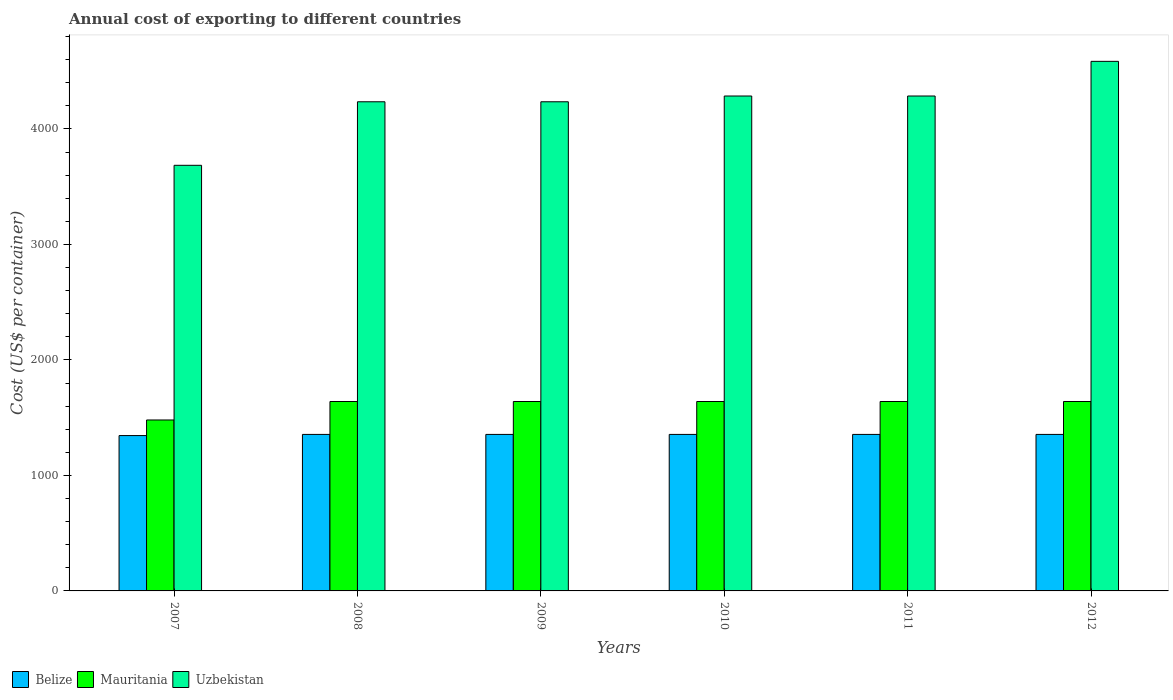How many bars are there on the 4th tick from the left?
Your answer should be compact. 3. How many bars are there on the 1st tick from the right?
Make the answer very short. 3. In how many cases, is the number of bars for a given year not equal to the number of legend labels?
Provide a short and direct response. 0. What is the total annual cost of exporting in Belize in 2009?
Give a very brief answer. 1355. Across all years, what is the maximum total annual cost of exporting in Belize?
Provide a short and direct response. 1355. Across all years, what is the minimum total annual cost of exporting in Belize?
Keep it short and to the point. 1345. In which year was the total annual cost of exporting in Uzbekistan maximum?
Offer a very short reply. 2012. In which year was the total annual cost of exporting in Uzbekistan minimum?
Your answer should be compact. 2007. What is the total total annual cost of exporting in Mauritania in the graph?
Your answer should be very brief. 9680. What is the difference between the total annual cost of exporting in Uzbekistan in 2007 and that in 2012?
Offer a terse response. -900. What is the difference between the total annual cost of exporting in Uzbekistan in 2010 and the total annual cost of exporting in Mauritania in 2009?
Your response must be concise. 2645. What is the average total annual cost of exporting in Belize per year?
Offer a terse response. 1353.33. In the year 2007, what is the difference between the total annual cost of exporting in Uzbekistan and total annual cost of exporting in Belize?
Your response must be concise. 2340. What is the ratio of the total annual cost of exporting in Belize in 2008 to that in 2010?
Give a very brief answer. 1. What is the difference between the highest and the second highest total annual cost of exporting in Uzbekistan?
Provide a short and direct response. 300. What is the difference between the highest and the lowest total annual cost of exporting in Belize?
Keep it short and to the point. 10. What does the 1st bar from the left in 2009 represents?
Your answer should be compact. Belize. What does the 2nd bar from the right in 2009 represents?
Your response must be concise. Mauritania. Is it the case that in every year, the sum of the total annual cost of exporting in Belize and total annual cost of exporting in Uzbekistan is greater than the total annual cost of exporting in Mauritania?
Your response must be concise. Yes. Are all the bars in the graph horizontal?
Your response must be concise. No. What is the difference between two consecutive major ticks on the Y-axis?
Your answer should be compact. 1000. Are the values on the major ticks of Y-axis written in scientific E-notation?
Offer a very short reply. No. Does the graph contain any zero values?
Your answer should be very brief. No. How many legend labels are there?
Your answer should be very brief. 3. How are the legend labels stacked?
Ensure brevity in your answer.  Horizontal. What is the title of the graph?
Offer a terse response. Annual cost of exporting to different countries. Does "Latin America(developing only)" appear as one of the legend labels in the graph?
Ensure brevity in your answer.  No. What is the label or title of the Y-axis?
Your answer should be very brief. Cost (US$ per container). What is the Cost (US$ per container) in Belize in 2007?
Provide a succinct answer. 1345. What is the Cost (US$ per container) in Mauritania in 2007?
Provide a succinct answer. 1480. What is the Cost (US$ per container) of Uzbekistan in 2007?
Offer a very short reply. 3685. What is the Cost (US$ per container) in Belize in 2008?
Give a very brief answer. 1355. What is the Cost (US$ per container) of Mauritania in 2008?
Your answer should be very brief. 1640. What is the Cost (US$ per container) in Uzbekistan in 2008?
Keep it short and to the point. 4235. What is the Cost (US$ per container) in Belize in 2009?
Your answer should be compact. 1355. What is the Cost (US$ per container) in Mauritania in 2009?
Ensure brevity in your answer.  1640. What is the Cost (US$ per container) of Uzbekistan in 2009?
Your answer should be compact. 4235. What is the Cost (US$ per container) of Belize in 2010?
Offer a very short reply. 1355. What is the Cost (US$ per container) of Mauritania in 2010?
Keep it short and to the point. 1640. What is the Cost (US$ per container) of Uzbekistan in 2010?
Your answer should be compact. 4285. What is the Cost (US$ per container) in Belize in 2011?
Keep it short and to the point. 1355. What is the Cost (US$ per container) in Mauritania in 2011?
Keep it short and to the point. 1640. What is the Cost (US$ per container) in Uzbekistan in 2011?
Ensure brevity in your answer.  4285. What is the Cost (US$ per container) in Belize in 2012?
Ensure brevity in your answer.  1355. What is the Cost (US$ per container) in Mauritania in 2012?
Offer a terse response. 1640. What is the Cost (US$ per container) in Uzbekistan in 2012?
Give a very brief answer. 4585. Across all years, what is the maximum Cost (US$ per container) of Belize?
Provide a short and direct response. 1355. Across all years, what is the maximum Cost (US$ per container) in Mauritania?
Your response must be concise. 1640. Across all years, what is the maximum Cost (US$ per container) in Uzbekistan?
Make the answer very short. 4585. Across all years, what is the minimum Cost (US$ per container) in Belize?
Your answer should be compact. 1345. Across all years, what is the minimum Cost (US$ per container) in Mauritania?
Offer a very short reply. 1480. Across all years, what is the minimum Cost (US$ per container) of Uzbekistan?
Keep it short and to the point. 3685. What is the total Cost (US$ per container) in Belize in the graph?
Offer a very short reply. 8120. What is the total Cost (US$ per container) in Mauritania in the graph?
Your answer should be compact. 9680. What is the total Cost (US$ per container) of Uzbekistan in the graph?
Keep it short and to the point. 2.53e+04. What is the difference between the Cost (US$ per container) of Mauritania in 2007 and that in 2008?
Make the answer very short. -160. What is the difference between the Cost (US$ per container) of Uzbekistan in 2007 and that in 2008?
Ensure brevity in your answer.  -550. What is the difference between the Cost (US$ per container) of Belize in 2007 and that in 2009?
Your answer should be very brief. -10. What is the difference between the Cost (US$ per container) in Mauritania in 2007 and that in 2009?
Make the answer very short. -160. What is the difference between the Cost (US$ per container) in Uzbekistan in 2007 and that in 2009?
Provide a short and direct response. -550. What is the difference between the Cost (US$ per container) of Belize in 2007 and that in 2010?
Keep it short and to the point. -10. What is the difference between the Cost (US$ per container) of Mauritania in 2007 and that in 2010?
Your response must be concise. -160. What is the difference between the Cost (US$ per container) of Uzbekistan in 2007 and that in 2010?
Provide a succinct answer. -600. What is the difference between the Cost (US$ per container) of Mauritania in 2007 and that in 2011?
Your answer should be very brief. -160. What is the difference between the Cost (US$ per container) of Uzbekistan in 2007 and that in 2011?
Your answer should be very brief. -600. What is the difference between the Cost (US$ per container) of Mauritania in 2007 and that in 2012?
Provide a short and direct response. -160. What is the difference between the Cost (US$ per container) of Uzbekistan in 2007 and that in 2012?
Your response must be concise. -900. What is the difference between the Cost (US$ per container) of Belize in 2008 and that in 2009?
Offer a terse response. 0. What is the difference between the Cost (US$ per container) of Mauritania in 2008 and that in 2009?
Provide a succinct answer. 0. What is the difference between the Cost (US$ per container) of Mauritania in 2008 and that in 2010?
Keep it short and to the point. 0. What is the difference between the Cost (US$ per container) in Uzbekistan in 2008 and that in 2010?
Offer a terse response. -50. What is the difference between the Cost (US$ per container) of Belize in 2008 and that in 2011?
Ensure brevity in your answer.  0. What is the difference between the Cost (US$ per container) of Uzbekistan in 2008 and that in 2011?
Offer a terse response. -50. What is the difference between the Cost (US$ per container) in Uzbekistan in 2008 and that in 2012?
Offer a very short reply. -350. What is the difference between the Cost (US$ per container) in Mauritania in 2009 and that in 2010?
Your response must be concise. 0. What is the difference between the Cost (US$ per container) of Uzbekistan in 2009 and that in 2010?
Your response must be concise. -50. What is the difference between the Cost (US$ per container) of Uzbekistan in 2009 and that in 2012?
Ensure brevity in your answer.  -350. What is the difference between the Cost (US$ per container) in Belize in 2010 and that in 2011?
Give a very brief answer. 0. What is the difference between the Cost (US$ per container) in Uzbekistan in 2010 and that in 2011?
Your answer should be very brief. 0. What is the difference between the Cost (US$ per container) of Belize in 2010 and that in 2012?
Provide a succinct answer. 0. What is the difference between the Cost (US$ per container) in Mauritania in 2010 and that in 2012?
Make the answer very short. 0. What is the difference between the Cost (US$ per container) of Uzbekistan in 2010 and that in 2012?
Give a very brief answer. -300. What is the difference between the Cost (US$ per container) in Mauritania in 2011 and that in 2012?
Your response must be concise. 0. What is the difference between the Cost (US$ per container) in Uzbekistan in 2011 and that in 2012?
Give a very brief answer. -300. What is the difference between the Cost (US$ per container) in Belize in 2007 and the Cost (US$ per container) in Mauritania in 2008?
Keep it short and to the point. -295. What is the difference between the Cost (US$ per container) in Belize in 2007 and the Cost (US$ per container) in Uzbekistan in 2008?
Ensure brevity in your answer.  -2890. What is the difference between the Cost (US$ per container) of Mauritania in 2007 and the Cost (US$ per container) of Uzbekistan in 2008?
Offer a terse response. -2755. What is the difference between the Cost (US$ per container) in Belize in 2007 and the Cost (US$ per container) in Mauritania in 2009?
Your answer should be compact. -295. What is the difference between the Cost (US$ per container) of Belize in 2007 and the Cost (US$ per container) of Uzbekistan in 2009?
Make the answer very short. -2890. What is the difference between the Cost (US$ per container) of Mauritania in 2007 and the Cost (US$ per container) of Uzbekistan in 2009?
Offer a terse response. -2755. What is the difference between the Cost (US$ per container) of Belize in 2007 and the Cost (US$ per container) of Mauritania in 2010?
Ensure brevity in your answer.  -295. What is the difference between the Cost (US$ per container) of Belize in 2007 and the Cost (US$ per container) of Uzbekistan in 2010?
Offer a very short reply. -2940. What is the difference between the Cost (US$ per container) in Mauritania in 2007 and the Cost (US$ per container) in Uzbekistan in 2010?
Ensure brevity in your answer.  -2805. What is the difference between the Cost (US$ per container) in Belize in 2007 and the Cost (US$ per container) in Mauritania in 2011?
Your answer should be very brief. -295. What is the difference between the Cost (US$ per container) in Belize in 2007 and the Cost (US$ per container) in Uzbekistan in 2011?
Offer a terse response. -2940. What is the difference between the Cost (US$ per container) of Mauritania in 2007 and the Cost (US$ per container) of Uzbekistan in 2011?
Provide a succinct answer. -2805. What is the difference between the Cost (US$ per container) in Belize in 2007 and the Cost (US$ per container) in Mauritania in 2012?
Your answer should be very brief. -295. What is the difference between the Cost (US$ per container) in Belize in 2007 and the Cost (US$ per container) in Uzbekistan in 2012?
Provide a succinct answer. -3240. What is the difference between the Cost (US$ per container) in Mauritania in 2007 and the Cost (US$ per container) in Uzbekistan in 2012?
Make the answer very short. -3105. What is the difference between the Cost (US$ per container) of Belize in 2008 and the Cost (US$ per container) of Mauritania in 2009?
Give a very brief answer. -285. What is the difference between the Cost (US$ per container) of Belize in 2008 and the Cost (US$ per container) of Uzbekistan in 2009?
Make the answer very short. -2880. What is the difference between the Cost (US$ per container) in Mauritania in 2008 and the Cost (US$ per container) in Uzbekistan in 2009?
Your response must be concise. -2595. What is the difference between the Cost (US$ per container) of Belize in 2008 and the Cost (US$ per container) of Mauritania in 2010?
Ensure brevity in your answer.  -285. What is the difference between the Cost (US$ per container) of Belize in 2008 and the Cost (US$ per container) of Uzbekistan in 2010?
Provide a succinct answer. -2930. What is the difference between the Cost (US$ per container) in Mauritania in 2008 and the Cost (US$ per container) in Uzbekistan in 2010?
Keep it short and to the point. -2645. What is the difference between the Cost (US$ per container) of Belize in 2008 and the Cost (US$ per container) of Mauritania in 2011?
Your answer should be very brief. -285. What is the difference between the Cost (US$ per container) in Belize in 2008 and the Cost (US$ per container) in Uzbekistan in 2011?
Ensure brevity in your answer.  -2930. What is the difference between the Cost (US$ per container) of Mauritania in 2008 and the Cost (US$ per container) of Uzbekistan in 2011?
Provide a short and direct response. -2645. What is the difference between the Cost (US$ per container) of Belize in 2008 and the Cost (US$ per container) of Mauritania in 2012?
Your response must be concise. -285. What is the difference between the Cost (US$ per container) of Belize in 2008 and the Cost (US$ per container) of Uzbekistan in 2012?
Your answer should be very brief. -3230. What is the difference between the Cost (US$ per container) in Mauritania in 2008 and the Cost (US$ per container) in Uzbekistan in 2012?
Offer a terse response. -2945. What is the difference between the Cost (US$ per container) of Belize in 2009 and the Cost (US$ per container) of Mauritania in 2010?
Your response must be concise. -285. What is the difference between the Cost (US$ per container) of Belize in 2009 and the Cost (US$ per container) of Uzbekistan in 2010?
Your response must be concise. -2930. What is the difference between the Cost (US$ per container) of Mauritania in 2009 and the Cost (US$ per container) of Uzbekistan in 2010?
Your answer should be compact. -2645. What is the difference between the Cost (US$ per container) of Belize in 2009 and the Cost (US$ per container) of Mauritania in 2011?
Offer a very short reply. -285. What is the difference between the Cost (US$ per container) in Belize in 2009 and the Cost (US$ per container) in Uzbekistan in 2011?
Your response must be concise. -2930. What is the difference between the Cost (US$ per container) of Mauritania in 2009 and the Cost (US$ per container) of Uzbekistan in 2011?
Keep it short and to the point. -2645. What is the difference between the Cost (US$ per container) in Belize in 2009 and the Cost (US$ per container) in Mauritania in 2012?
Make the answer very short. -285. What is the difference between the Cost (US$ per container) in Belize in 2009 and the Cost (US$ per container) in Uzbekistan in 2012?
Your response must be concise. -3230. What is the difference between the Cost (US$ per container) of Mauritania in 2009 and the Cost (US$ per container) of Uzbekistan in 2012?
Give a very brief answer. -2945. What is the difference between the Cost (US$ per container) in Belize in 2010 and the Cost (US$ per container) in Mauritania in 2011?
Ensure brevity in your answer.  -285. What is the difference between the Cost (US$ per container) in Belize in 2010 and the Cost (US$ per container) in Uzbekistan in 2011?
Make the answer very short. -2930. What is the difference between the Cost (US$ per container) of Mauritania in 2010 and the Cost (US$ per container) of Uzbekistan in 2011?
Your answer should be very brief. -2645. What is the difference between the Cost (US$ per container) of Belize in 2010 and the Cost (US$ per container) of Mauritania in 2012?
Provide a succinct answer. -285. What is the difference between the Cost (US$ per container) of Belize in 2010 and the Cost (US$ per container) of Uzbekistan in 2012?
Ensure brevity in your answer.  -3230. What is the difference between the Cost (US$ per container) of Mauritania in 2010 and the Cost (US$ per container) of Uzbekistan in 2012?
Ensure brevity in your answer.  -2945. What is the difference between the Cost (US$ per container) of Belize in 2011 and the Cost (US$ per container) of Mauritania in 2012?
Provide a short and direct response. -285. What is the difference between the Cost (US$ per container) of Belize in 2011 and the Cost (US$ per container) of Uzbekistan in 2012?
Offer a very short reply. -3230. What is the difference between the Cost (US$ per container) of Mauritania in 2011 and the Cost (US$ per container) of Uzbekistan in 2012?
Offer a terse response. -2945. What is the average Cost (US$ per container) in Belize per year?
Provide a short and direct response. 1353.33. What is the average Cost (US$ per container) in Mauritania per year?
Offer a very short reply. 1613.33. What is the average Cost (US$ per container) in Uzbekistan per year?
Your answer should be compact. 4218.33. In the year 2007, what is the difference between the Cost (US$ per container) of Belize and Cost (US$ per container) of Mauritania?
Your response must be concise. -135. In the year 2007, what is the difference between the Cost (US$ per container) in Belize and Cost (US$ per container) in Uzbekistan?
Provide a succinct answer. -2340. In the year 2007, what is the difference between the Cost (US$ per container) of Mauritania and Cost (US$ per container) of Uzbekistan?
Your answer should be compact. -2205. In the year 2008, what is the difference between the Cost (US$ per container) of Belize and Cost (US$ per container) of Mauritania?
Your answer should be compact. -285. In the year 2008, what is the difference between the Cost (US$ per container) in Belize and Cost (US$ per container) in Uzbekistan?
Ensure brevity in your answer.  -2880. In the year 2008, what is the difference between the Cost (US$ per container) of Mauritania and Cost (US$ per container) of Uzbekistan?
Your response must be concise. -2595. In the year 2009, what is the difference between the Cost (US$ per container) of Belize and Cost (US$ per container) of Mauritania?
Ensure brevity in your answer.  -285. In the year 2009, what is the difference between the Cost (US$ per container) in Belize and Cost (US$ per container) in Uzbekistan?
Offer a very short reply. -2880. In the year 2009, what is the difference between the Cost (US$ per container) of Mauritania and Cost (US$ per container) of Uzbekistan?
Offer a very short reply. -2595. In the year 2010, what is the difference between the Cost (US$ per container) of Belize and Cost (US$ per container) of Mauritania?
Provide a short and direct response. -285. In the year 2010, what is the difference between the Cost (US$ per container) of Belize and Cost (US$ per container) of Uzbekistan?
Provide a succinct answer. -2930. In the year 2010, what is the difference between the Cost (US$ per container) in Mauritania and Cost (US$ per container) in Uzbekistan?
Your answer should be compact. -2645. In the year 2011, what is the difference between the Cost (US$ per container) in Belize and Cost (US$ per container) in Mauritania?
Give a very brief answer. -285. In the year 2011, what is the difference between the Cost (US$ per container) of Belize and Cost (US$ per container) of Uzbekistan?
Give a very brief answer. -2930. In the year 2011, what is the difference between the Cost (US$ per container) in Mauritania and Cost (US$ per container) in Uzbekistan?
Your answer should be compact. -2645. In the year 2012, what is the difference between the Cost (US$ per container) in Belize and Cost (US$ per container) in Mauritania?
Offer a very short reply. -285. In the year 2012, what is the difference between the Cost (US$ per container) in Belize and Cost (US$ per container) in Uzbekistan?
Ensure brevity in your answer.  -3230. In the year 2012, what is the difference between the Cost (US$ per container) of Mauritania and Cost (US$ per container) of Uzbekistan?
Your response must be concise. -2945. What is the ratio of the Cost (US$ per container) of Mauritania in 2007 to that in 2008?
Provide a succinct answer. 0.9. What is the ratio of the Cost (US$ per container) in Uzbekistan in 2007 to that in 2008?
Give a very brief answer. 0.87. What is the ratio of the Cost (US$ per container) in Mauritania in 2007 to that in 2009?
Provide a short and direct response. 0.9. What is the ratio of the Cost (US$ per container) of Uzbekistan in 2007 to that in 2009?
Offer a terse response. 0.87. What is the ratio of the Cost (US$ per container) in Mauritania in 2007 to that in 2010?
Your answer should be very brief. 0.9. What is the ratio of the Cost (US$ per container) in Uzbekistan in 2007 to that in 2010?
Make the answer very short. 0.86. What is the ratio of the Cost (US$ per container) of Mauritania in 2007 to that in 2011?
Provide a short and direct response. 0.9. What is the ratio of the Cost (US$ per container) of Uzbekistan in 2007 to that in 2011?
Your answer should be very brief. 0.86. What is the ratio of the Cost (US$ per container) of Belize in 2007 to that in 2012?
Give a very brief answer. 0.99. What is the ratio of the Cost (US$ per container) in Mauritania in 2007 to that in 2012?
Provide a succinct answer. 0.9. What is the ratio of the Cost (US$ per container) in Uzbekistan in 2007 to that in 2012?
Your answer should be very brief. 0.8. What is the ratio of the Cost (US$ per container) in Belize in 2008 to that in 2009?
Provide a succinct answer. 1. What is the ratio of the Cost (US$ per container) in Mauritania in 2008 to that in 2009?
Make the answer very short. 1. What is the ratio of the Cost (US$ per container) of Uzbekistan in 2008 to that in 2009?
Offer a very short reply. 1. What is the ratio of the Cost (US$ per container) in Mauritania in 2008 to that in 2010?
Offer a terse response. 1. What is the ratio of the Cost (US$ per container) in Uzbekistan in 2008 to that in 2010?
Provide a short and direct response. 0.99. What is the ratio of the Cost (US$ per container) of Belize in 2008 to that in 2011?
Make the answer very short. 1. What is the ratio of the Cost (US$ per container) of Uzbekistan in 2008 to that in 2011?
Your response must be concise. 0.99. What is the ratio of the Cost (US$ per container) of Belize in 2008 to that in 2012?
Provide a short and direct response. 1. What is the ratio of the Cost (US$ per container) of Mauritania in 2008 to that in 2012?
Your answer should be very brief. 1. What is the ratio of the Cost (US$ per container) of Uzbekistan in 2008 to that in 2012?
Your answer should be compact. 0.92. What is the ratio of the Cost (US$ per container) of Mauritania in 2009 to that in 2010?
Provide a short and direct response. 1. What is the ratio of the Cost (US$ per container) in Uzbekistan in 2009 to that in 2010?
Provide a succinct answer. 0.99. What is the ratio of the Cost (US$ per container) of Uzbekistan in 2009 to that in 2011?
Provide a short and direct response. 0.99. What is the ratio of the Cost (US$ per container) of Uzbekistan in 2009 to that in 2012?
Provide a short and direct response. 0.92. What is the ratio of the Cost (US$ per container) of Belize in 2010 to that in 2012?
Offer a very short reply. 1. What is the ratio of the Cost (US$ per container) of Mauritania in 2010 to that in 2012?
Make the answer very short. 1. What is the ratio of the Cost (US$ per container) in Uzbekistan in 2010 to that in 2012?
Give a very brief answer. 0.93. What is the ratio of the Cost (US$ per container) in Belize in 2011 to that in 2012?
Offer a very short reply. 1. What is the ratio of the Cost (US$ per container) in Mauritania in 2011 to that in 2012?
Your answer should be very brief. 1. What is the ratio of the Cost (US$ per container) of Uzbekistan in 2011 to that in 2012?
Provide a short and direct response. 0.93. What is the difference between the highest and the second highest Cost (US$ per container) in Belize?
Offer a very short reply. 0. What is the difference between the highest and the second highest Cost (US$ per container) of Uzbekistan?
Your response must be concise. 300. What is the difference between the highest and the lowest Cost (US$ per container) of Mauritania?
Ensure brevity in your answer.  160. What is the difference between the highest and the lowest Cost (US$ per container) of Uzbekistan?
Provide a succinct answer. 900. 